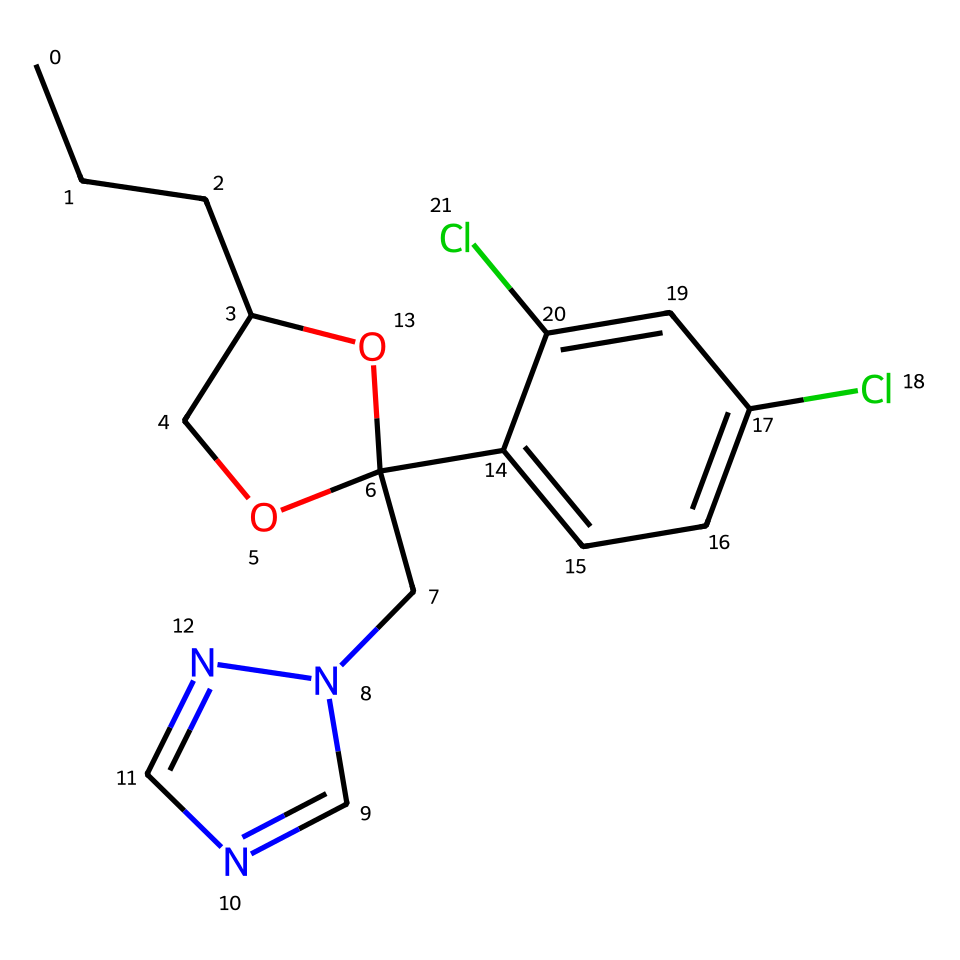how many rings are in this chemical structure? The chemical structure includes a cyclohexane-like ring (shown as part of the aromatic system) and another cyclic system containing an ether and a tetrahydrofuran moiety, totaling two distinct rings.
Answer: two what is the molecular weight of propiconazole? To determine the molecular weight, we can sum the atomic weights of all the atoms represented in the SMILES notation, which gives us approximately 265.7 g/mol for propiconazole.
Answer: 265.7 how many chlorine (Cl) atoms are present? Upon analyzing the structure, two chlorine substituents are visible in the aromatic portion, indicating that there are two Cl atoms present in the chemical compound.
Answer: two what functional groups are present in this fungicide? The structure features an ether (C-O-C), an alcohol (hydroxyl group, -OH), and an aromatic ring, which are all characteristic functional groups found in propiconazole.
Answer: ether, alcohol, aromatic is propiconazole classified as a broad-spectrum fungicide? Propiconazole is known for its broad-spectrum activity against a variety of fungal pathogens, making it suitable for diverse applications in agriculture and building materials, thus affirming its classification.
Answer: yes which part of the chemical structure contributes to its fungicidal activity? The presence of the imidazole ring (indicated in the structure) is crucial as it plays a significant role in inhibiting fungal growth by affecting the synthesis of ergosterol in fungal membranes.
Answer: imidazole ring how many nitrogen (N) atoms are present in the compound? Upon examining the structure, there is a total of two nitrogen atoms in the imidazole ring, which is a key part of the chemical's structure.
Answer: two 